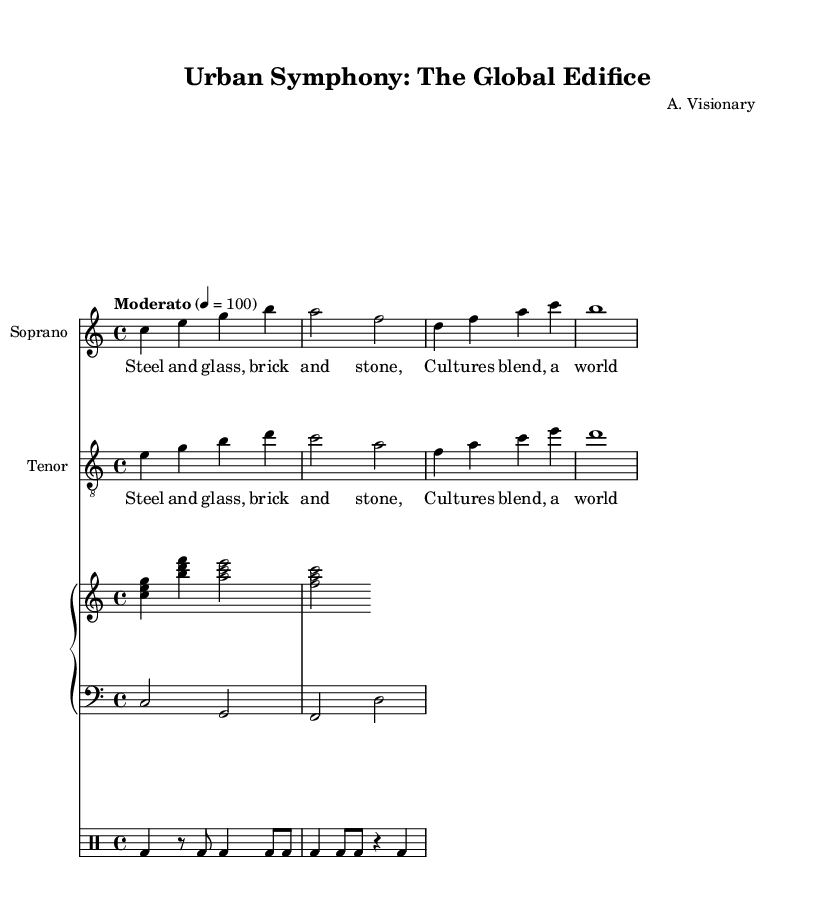What is the time signature of this music? The time signature is indicated at the beginning of the score and is in the format of beats per measure. In this case, it shows "4/4", meaning there are four beats in each measure.
Answer: 4/4 What is the tempo marking for this piece? The tempo marking is found at the start of the piece and indicates the speed. Here, it is labeled as "Moderato" and shows a metronomic marking of 100 beats per minute.
Answer: Moderato, 100 How many measures are in the soprano part? By counting the groups of bars in the soprano music section, we can determine the number of measures. The soprano part has four measures in total.
Answer: 4 What is the instrument name for the left-hand piano staff? The left-hand staff in the piano part is labeled with the clef "bass," which is typically used for lower-pitched instruments. It indicates that this part is played in a lower register.
Answer: Bass What are the lyrics sung by the tenor? The tenor lyrics are identical to those of the soprano and are presented below their respective music. They reflect the theme of the piece, emphasizing blending cultures.
Answer: Steel and glass, brick and stone, Cultures blend, a world our own How many different instrument types are used in this score? Observing the score layout, we notice several instrument parts: soprano, tenor, piano (with right and left staves), and percussion. This totals four distinct types of instruments present in the score.
Answer: 4 